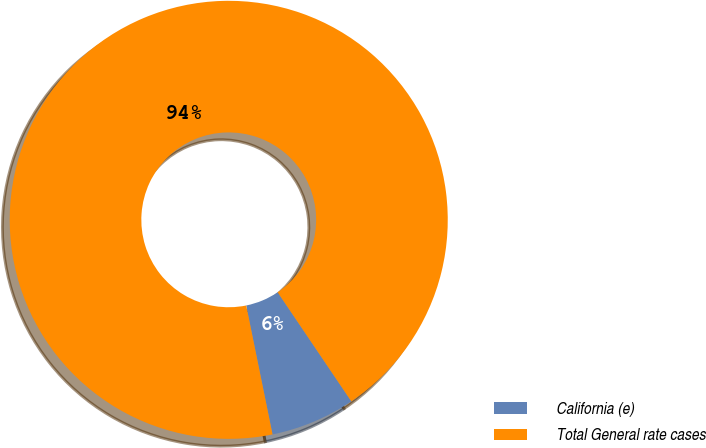Convert chart. <chart><loc_0><loc_0><loc_500><loc_500><pie_chart><fcel>California (e)<fcel>Total General rate cases<nl><fcel>6.25%<fcel>93.75%<nl></chart> 